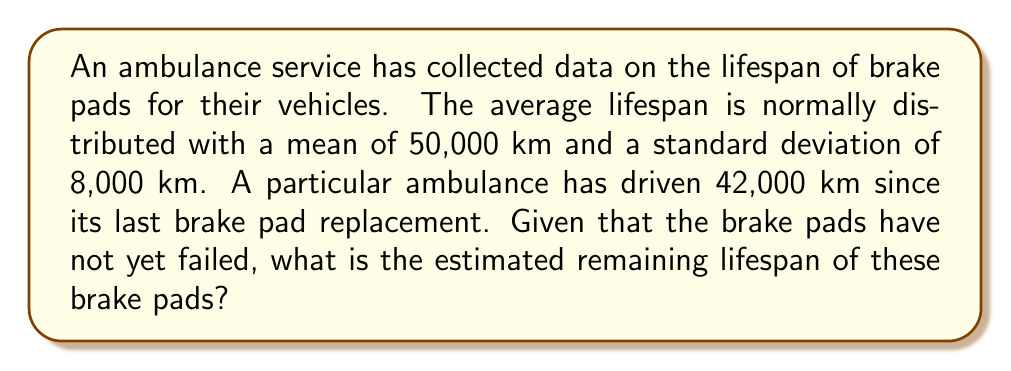Teach me how to tackle this problem. To solve this inverse problem, we'll use Bayesian inference:

1) Let $X$ be the total lifespan of the brake pads. We know $X \sim N(\mu=50000, \sigma=8000)$.

2) We've observed that $X > 42000$ (the current mileage without failure).

3) We want to find $E[X - 42000 | X > 42000]$.

4) First, calculate the standardized score for 42000:
   $$z = \frac{42000 - 50000}{8000} = -1$$

5) The probability of survival to 42000 km is:
   $$P(X > 42000) = 1 - \Phi(-1) = \Phi(1) \approx 0.8413$$
   where $\Phi$ is the standard normal cumulative distribution function.

6) The conditional probability density function is:
   $$f_{X|X>42000}(x) = \frac{f_X(x)}{P(X > 42000)} \text{ for } x > 42000$$

7) The expected value of this truncated normal distribution is:
   $$E[X|X>42000] = 50000 + 8000 \cdot \frac{\phi(-1)}{\Phi(1)}$$
   where $\phi$ is the standard normal probability density function.

8) Calculate:
   $$\frac{\phi(-1)}{\Phi(1)} = \frac{0.2420}{0.8413} \approx 0.2876$$

9) Therefore:
   $$E[X|X>42000] = 50000 + 8000 \cdot 0.2876 = 52301$$

10) The estimated remaining lifespan is:
    $$52301 - 42000 = 10301 \text{ km}$$
Answer: 10,301 km 